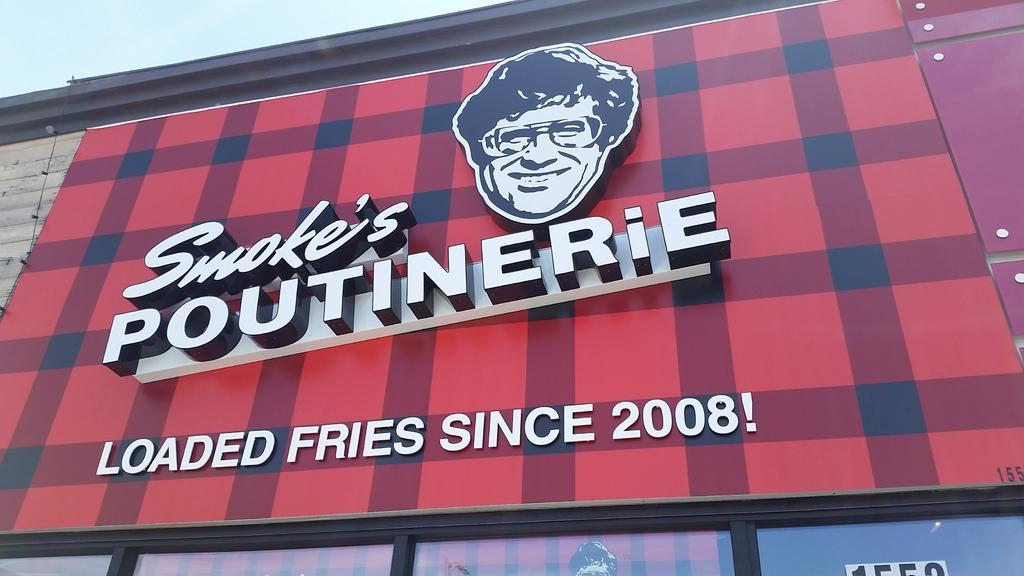What is present on the wall in the image? There is text and a person's image on the wall. What can be seen at the top of the image? The sky is visible at the top of the image. What type of machine is being driven by the men in the image? There are no men or machines present in the image; it only features a wall with text and a person's image. 